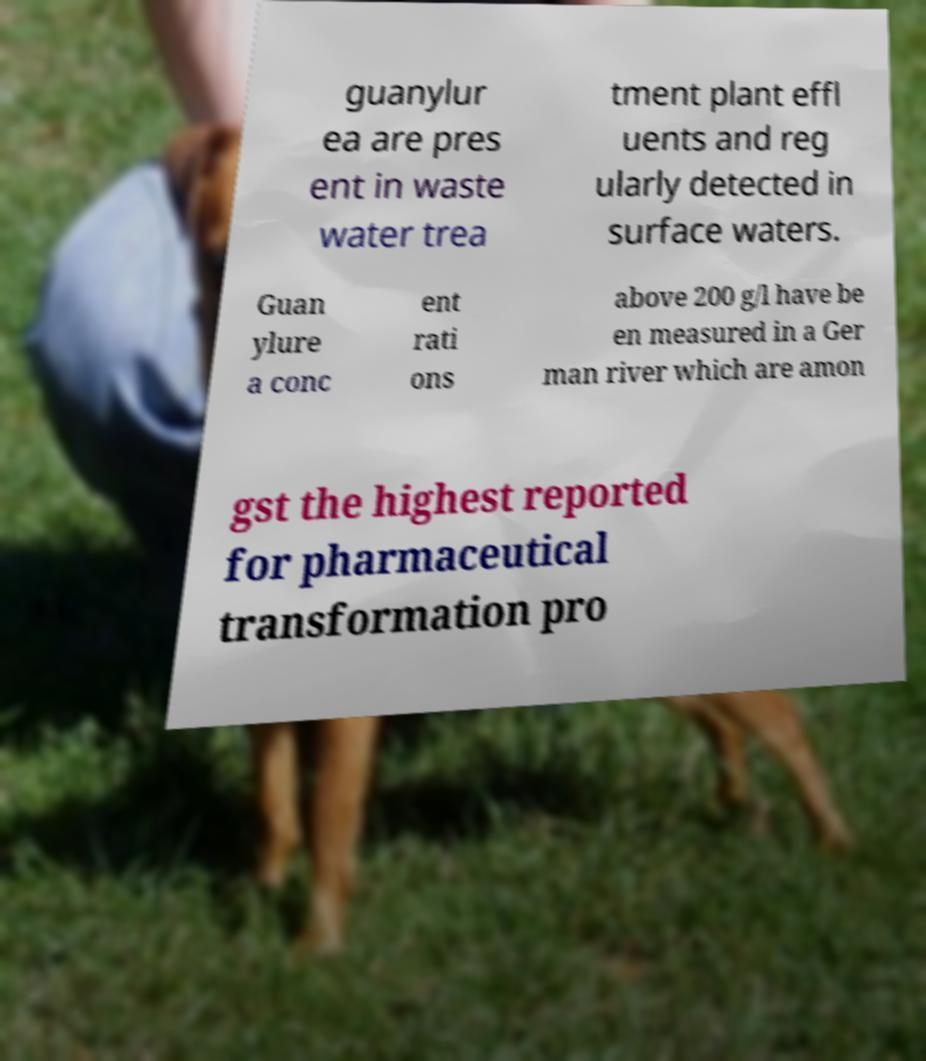Can you accurately transcribe the text from the provided image for me? guanylur ea are pres ent in waste water trea tment plant effl uents and reg ularly detected in surface waters. Guan ylure a conc ent rati ons above 200 g/l have be en measured in a Ger man river which are amon gst the highest reported for pharmaceutical transformation pro 